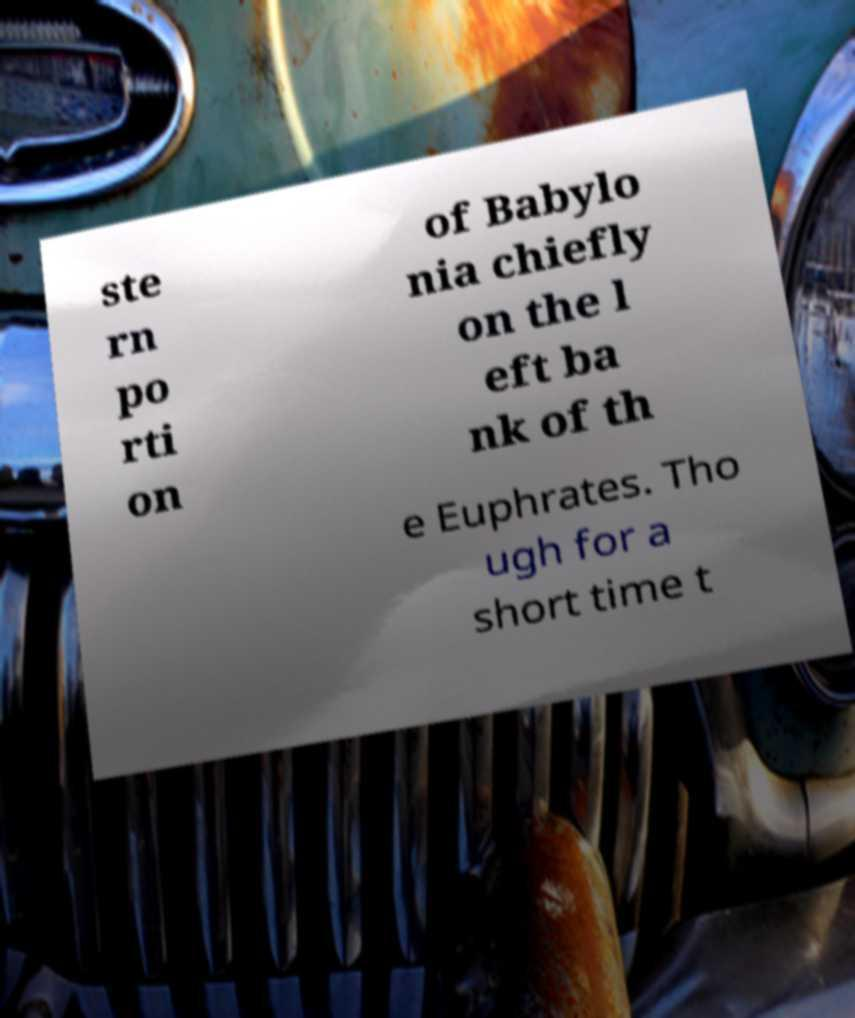Please identify and transcribe the text found in this image. ste rn po rti on of Babylo nia chiefly on the l eft ba nk of th e Euphrates. Tho ugh for a short time t 